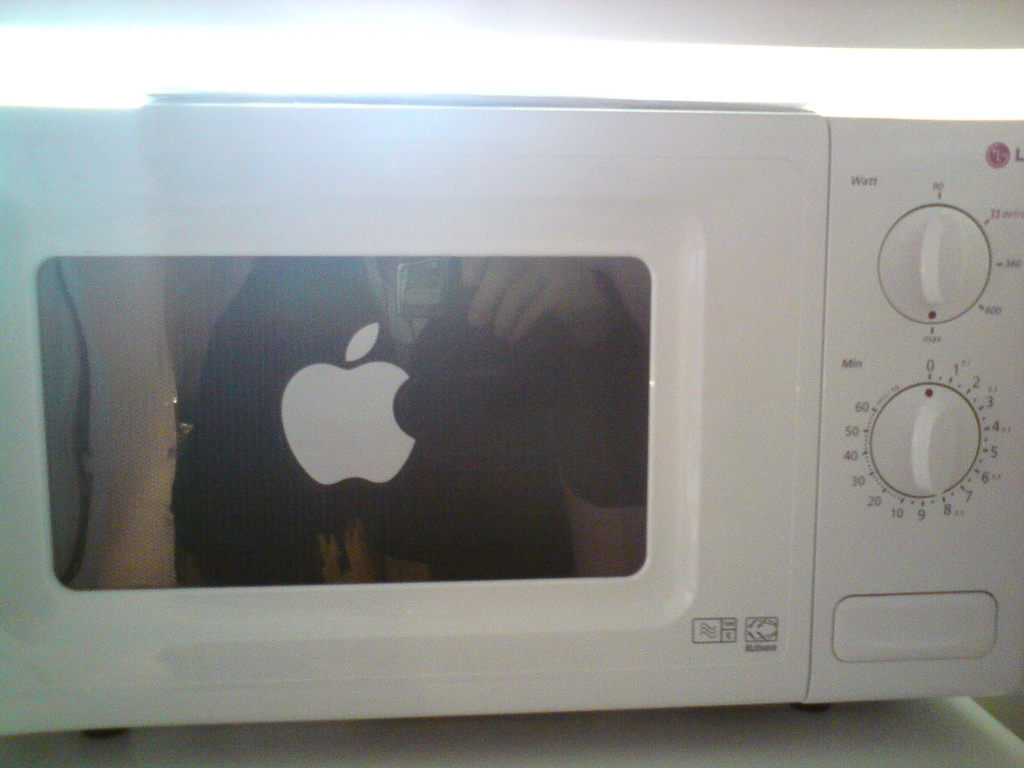Provide a one-sentence caption for the provided image. A white LG microwave oven sports an unconventional decoration: a shiny Apple logo sticker, playfully suggesting a blend of kitchen appliance with high-tech branding. 